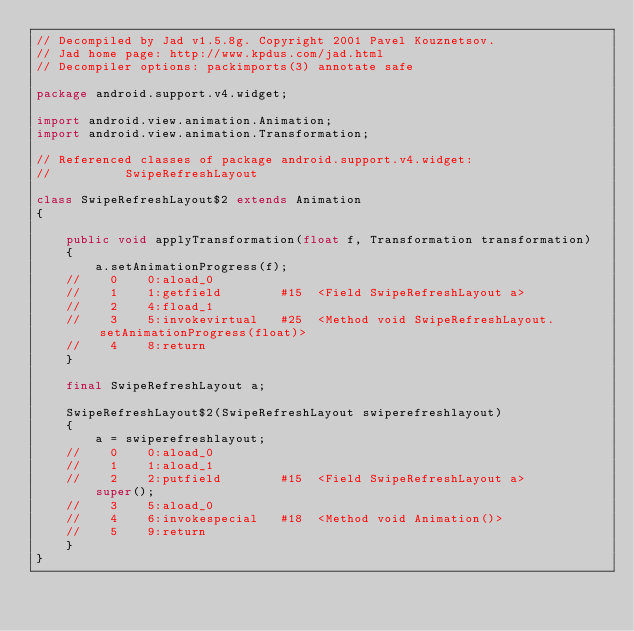<code> <loc_0><loc_0><loc_500><loc_500><_Java_>// Decompiled by Jad v1.5.8g. Copyright 2001 Pavel Kouznetsov.
// Jad home page: http://www.kpdus.com/jad.html
// Decompiler options: packimports(3) annotate safe 

package android.support.v4.widget;

import android.view.animation.Animation;
import android.view.animation.Transformation;

// Referenced classes of package android.support.v4.widget:
//			SwipeRefreshLayout

class SwipeRefreshLayout$2 extends Animation
{

	public void applyTransformation(float f, Transformation transformation)
	{
		a.setAnimationProgress(f);
	//    0    0:aload_0         
	//    1    1:getfield        #15  <Field SwipeRefreshLayout a>
	//    2    4:fload_1         
	//    3    5:invokevirtual   #25  <Method void SwipeRefreshLayout.setAnimationProgress(float)>
	//    4    8:return          
	}

	final SwipeRefreshLayout a;

	SwipeRefreshLayout$2(SwipeRefreshLayout swiperefreshlayout)
	{
		a = swiperefreshlayout;
	//    0    0:aload_0         
	//    1    1:aload_1         
	//    2    2:putfield        #15  <Field SwipeRefreshLayout a>
		super();
	//    3    5:aload_0         
	//    4    6:invokespecial   #18  <Method void Animation()>
	//    5    9:return          
	}
}
</code> 